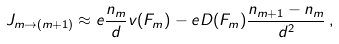Convert formula to latex. <formula><loc_0><loc_0><loc_500><loc_500>J _ { m \to ( m + 1 ) } \approx e \frac { n _ { m } } { d } v ( F _ { m } ) - e D ( F _ { m } ) \frac { n _ { m + 1 } - n _ { m } } { d ^ { 2 } } \, ,</formula> 